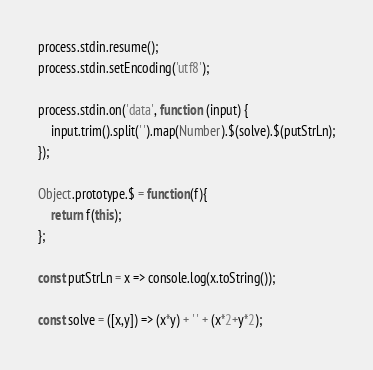<code> <loc_0><loc_0><loc_500><loc_500><_JavaScript_>process.stdin.resume();
process.stdin.setEncoding('utf8');

process.stdin.on('data', function (input) {
    input.trim().split(' ').map(Number).$(solve).$(putStrLn);
});

Object.prototype.$ = function(f){
    return f(this);
};

const putStrLn = x => console.log(x.toString());

const solve = ([x,y]) => (x*y) + ' ' + (x*2+y*2);</code> 